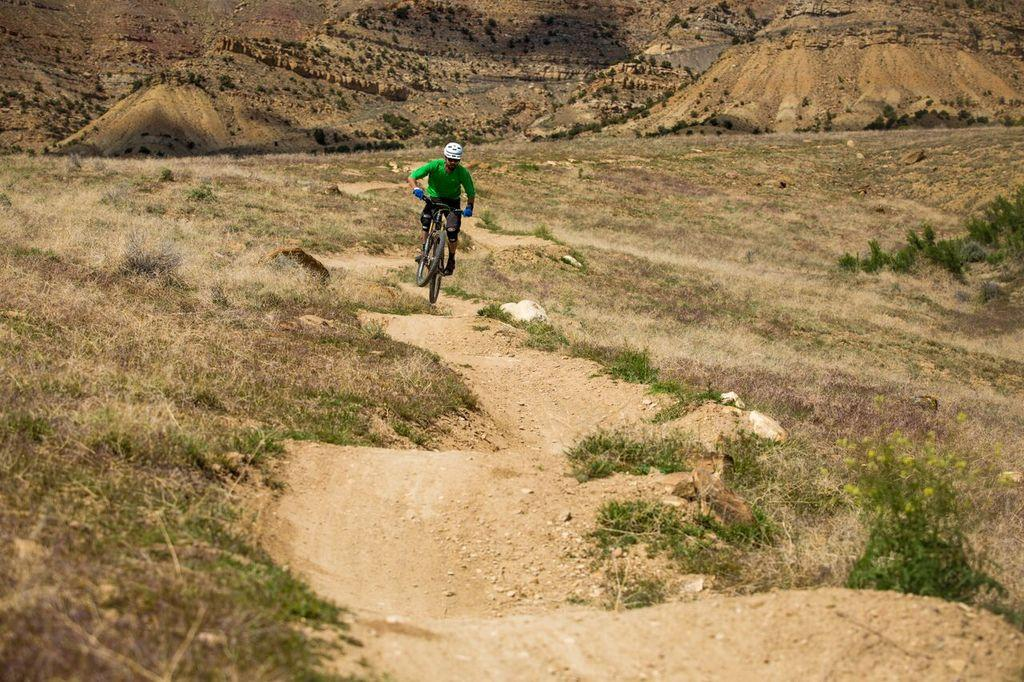What is the man in the image doing? The man is riding a bicycle in the image. What safety gear is the man wearing while riding the bicycle? The man is wearing a helmet and gloves. What type of vegetation can be seen in the image? There are plants and grass visible in the image. What song is the man singing while riding the bicycle in the image? There is no indication in the image that the man is singing a song, so it cannot be determined from the picture. 